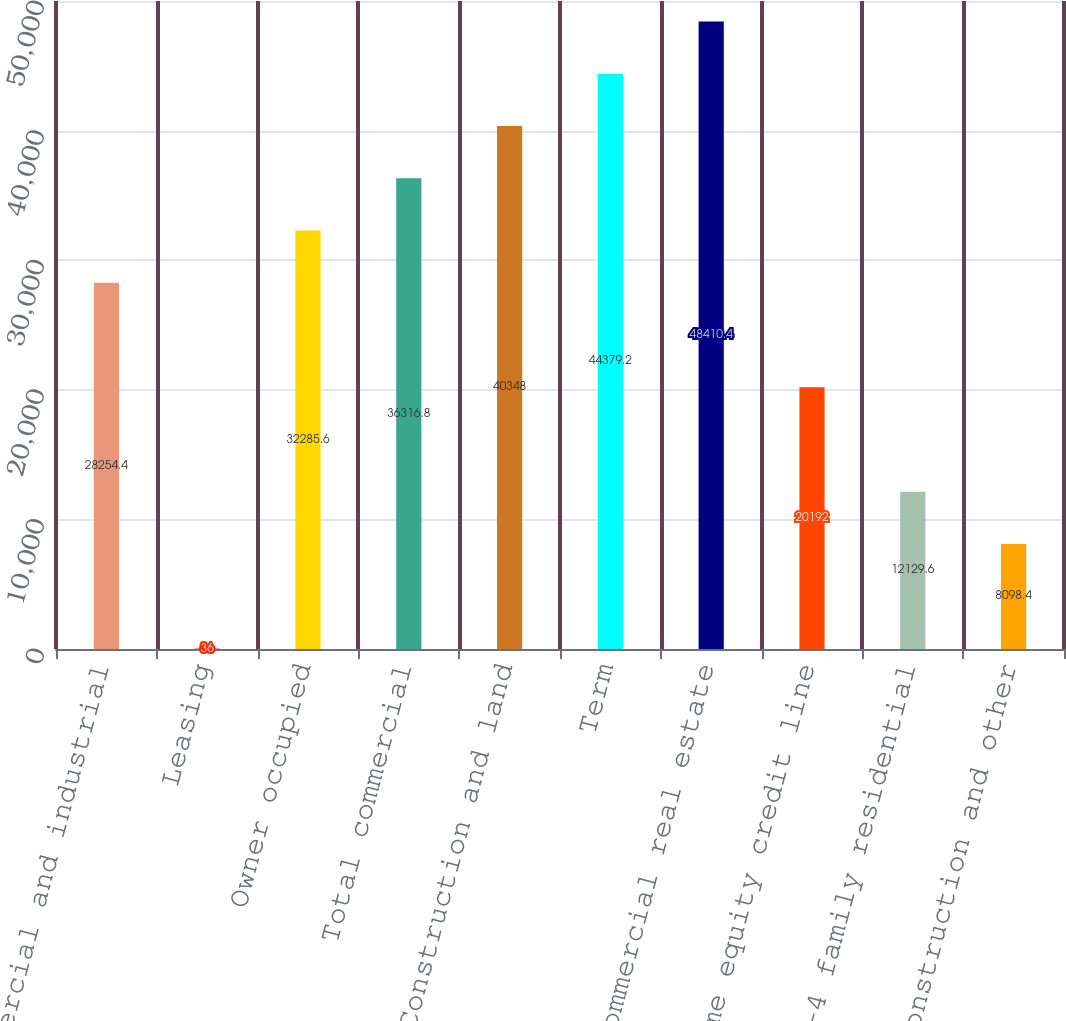Convert chart. <chart><loc_0><loc_0><loc_500><loc_500><bar_chart><fcel>Commercial and industrial<fcel>Leasing<fcel>Owner occupied<fcel>Total commercial<fcel>Construction and land<fcel>Term<fcel>Total commercial real estate<fcel>Home equity credit line<fcel>1-4 family residential<fcel>Construction and other<nl><fcel>28254.4<fcel>36<fcel>32285.6<fcel>36316.8<fcel>40348<fcel>44379.2<fcel>48410.4<fcel>20192<fcel>12129.6<fcel>8098.4<nl></chart> 